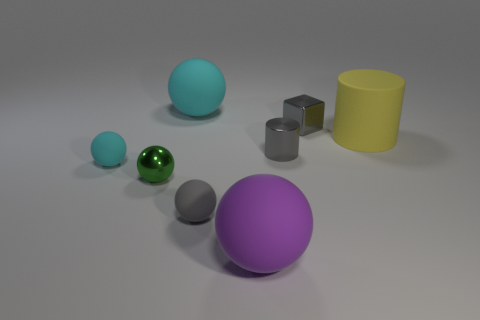Subtract all small cyan rubber balls. How many balls are left? 4 Subtract all gray balls. How many balls are left? 4 Subtract 1 cylinders. How many cylinders are left? 1 Add 1 blue cylinders. How many objects exist? 9 Subtract all cubes. How many objects are left? 7 Subtract all brown balls. How many yellow cylinders are left? 1 Subtract all cyan blocks. Subtract all cyan cylinders. How many blocks are left? 1 Subtract all rubber things. Subtract all large yellow matte things. How many objects are left? 2 Add 1 yellow cylinders. How many yellow cylinders are left? 2 Add 1 gray metallic cylinders. How many gray metallic cylinders exist? 2 